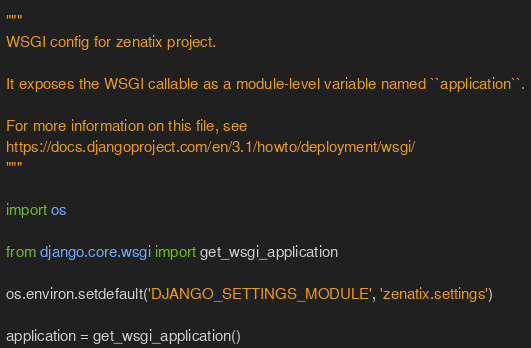<code> <loc_0><loc_0><loc_500><loc_500><_Python_>"""
WSGI config for zenatix project.

It exposes the WSGI callable as a module-level variable named ``application``.

For more information on this file, see
https://docs.djangoproject.com/en/3.1/howto/deployment/wsgi/
"""

import os

from django.core.wsgi import get_wsgi_application

os.environ.setdefault('DJANGO_SETTINGS_MODULE', 'zenatix.settings')

application = get_wsgi_application()
</code> 